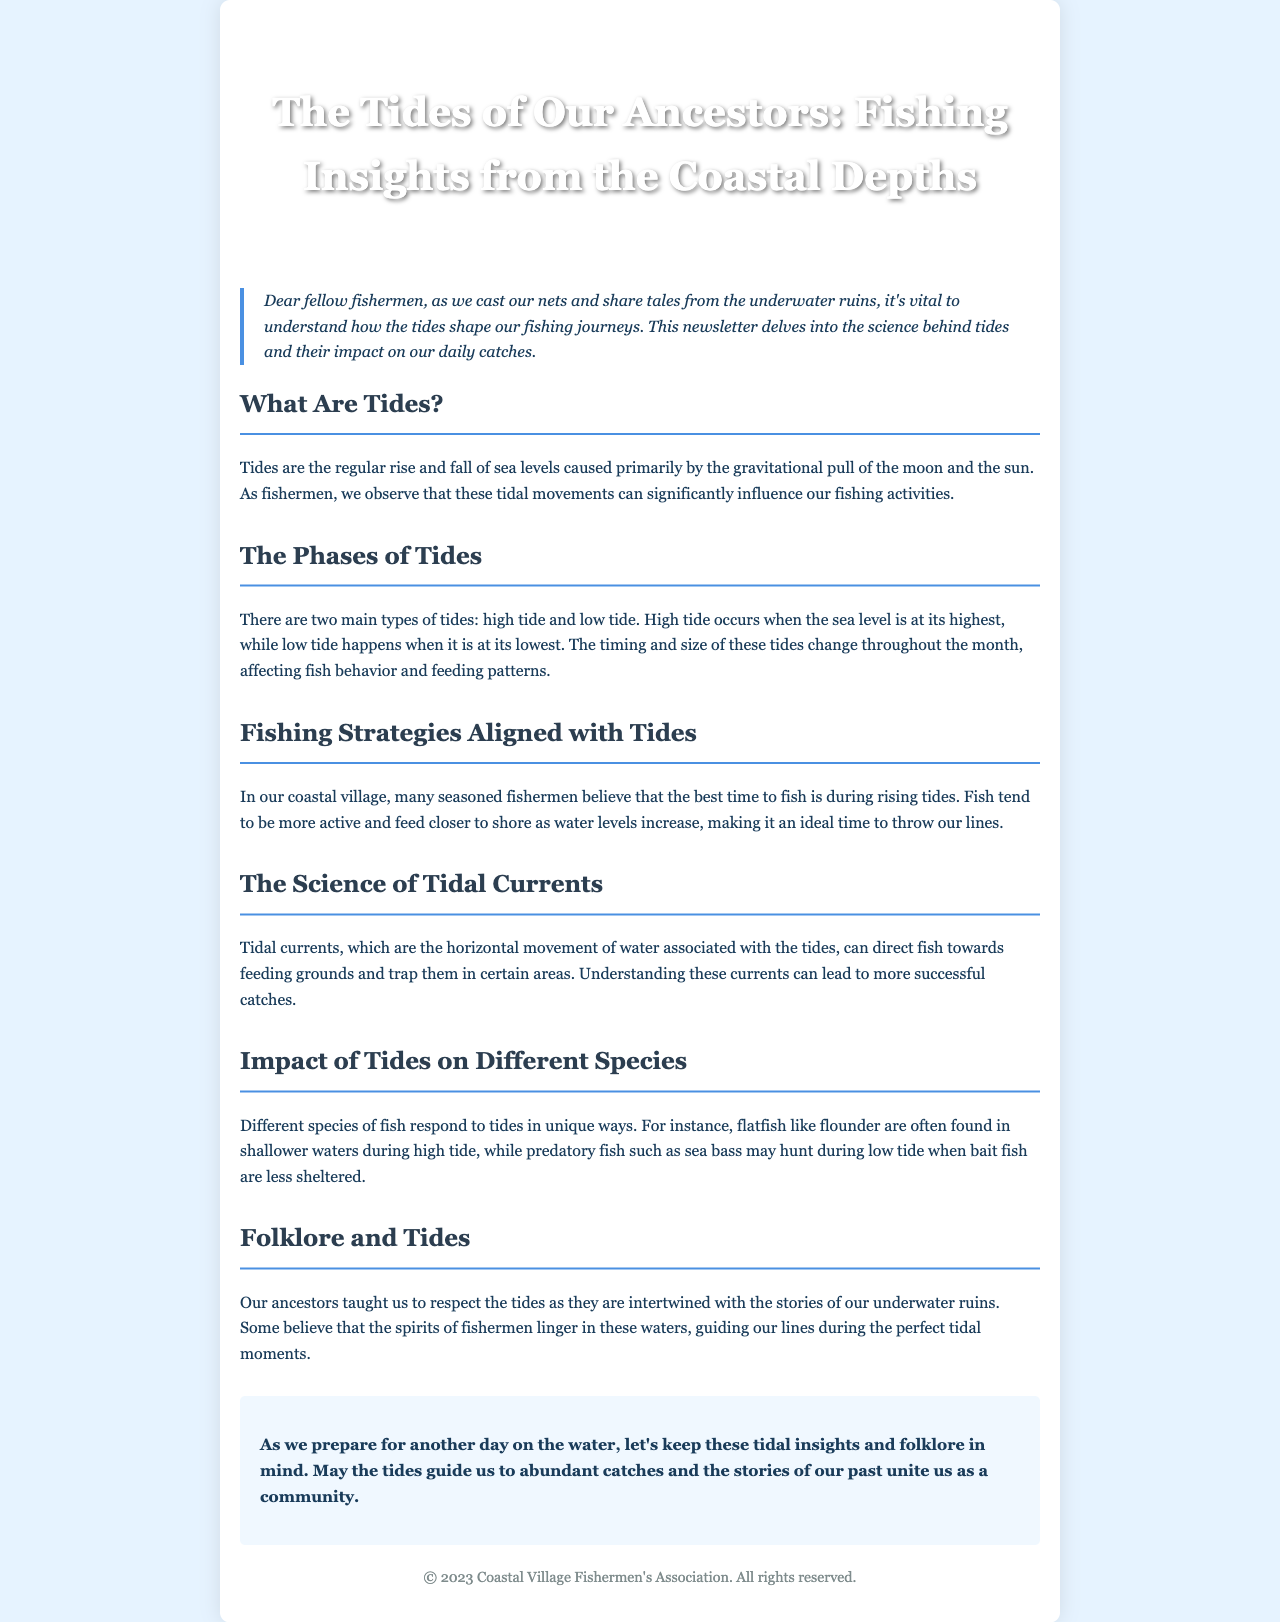What are tides? Tides are the regular rise and fall of sea levels caused primarily by the gravitational pull of the moon and the sun.
Answer: regular rise and fall of sea levels What are the two main types of tides? The document states that there are two main types of tides.
Answer: high tide and low tide When do fish tend to be more active according to local wisdom? The newsletter mentions that seasoned fishermen believe fish are more active during a specific tidal phase.
Answer: rising tides What unique behavior do flatfish like flounder exhibit during tides? The document specifies how flatfish respond to tidal changes.
Answer: found in shallower waters during high tide How can understanding tidal currents impact fishing success? The text explains that tidal currents can guide fish to feeding areas.
Answer: lead to more successful catches What folklore is associated with tides in the document? The newsletter discusses the connection between tides and the beliefs of ancestors.
Answer: spirits of fishermen linger in these waters 